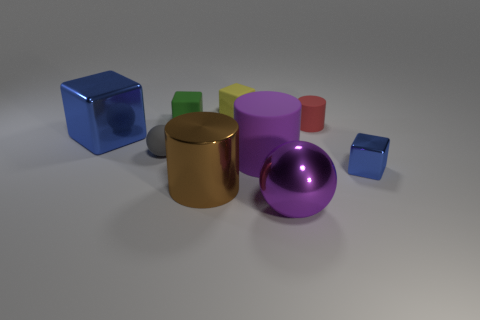There is a blue thing that is behind the tiny blue metal cube; is it the same size as the matte thing in front of the small sphere?
Make the answer very short. Yes. How many objects are gray things or large blue metallic objects?
Provide a short and direct response. 2. The tiny block on the right side of the rubber thing right of the large purple rubber object is made of what material?
Ensure brevity in your answer.  Metal. How many large shiny things are the same shape as the tiny blue object?
Provide a succinct answer. 1. Is there a shiny object that has the same color as the big rubber cylinder?
Make the answer very short. Yes. What number of objects are either blue objects to the left of the red rubber thing or tiny cylinders that are behind the purple metal object?
Provide a short and direct response. 2. There is a matte cylinder that is in front of the gray ball; are there any large purple objects that are in front of it?
Your response must be concise. Yes. The red thing that is the same size as the gray matte thing is what shape?
Provide a short and direct response. Cylinder. What number of objects are either metal cubes behind the small shiny cube or large brown rubber cylinders?
Provide a succinct answer. 1. How many other objects are the same material as the large brown cylinder?
Offer a very short reply. 3. 